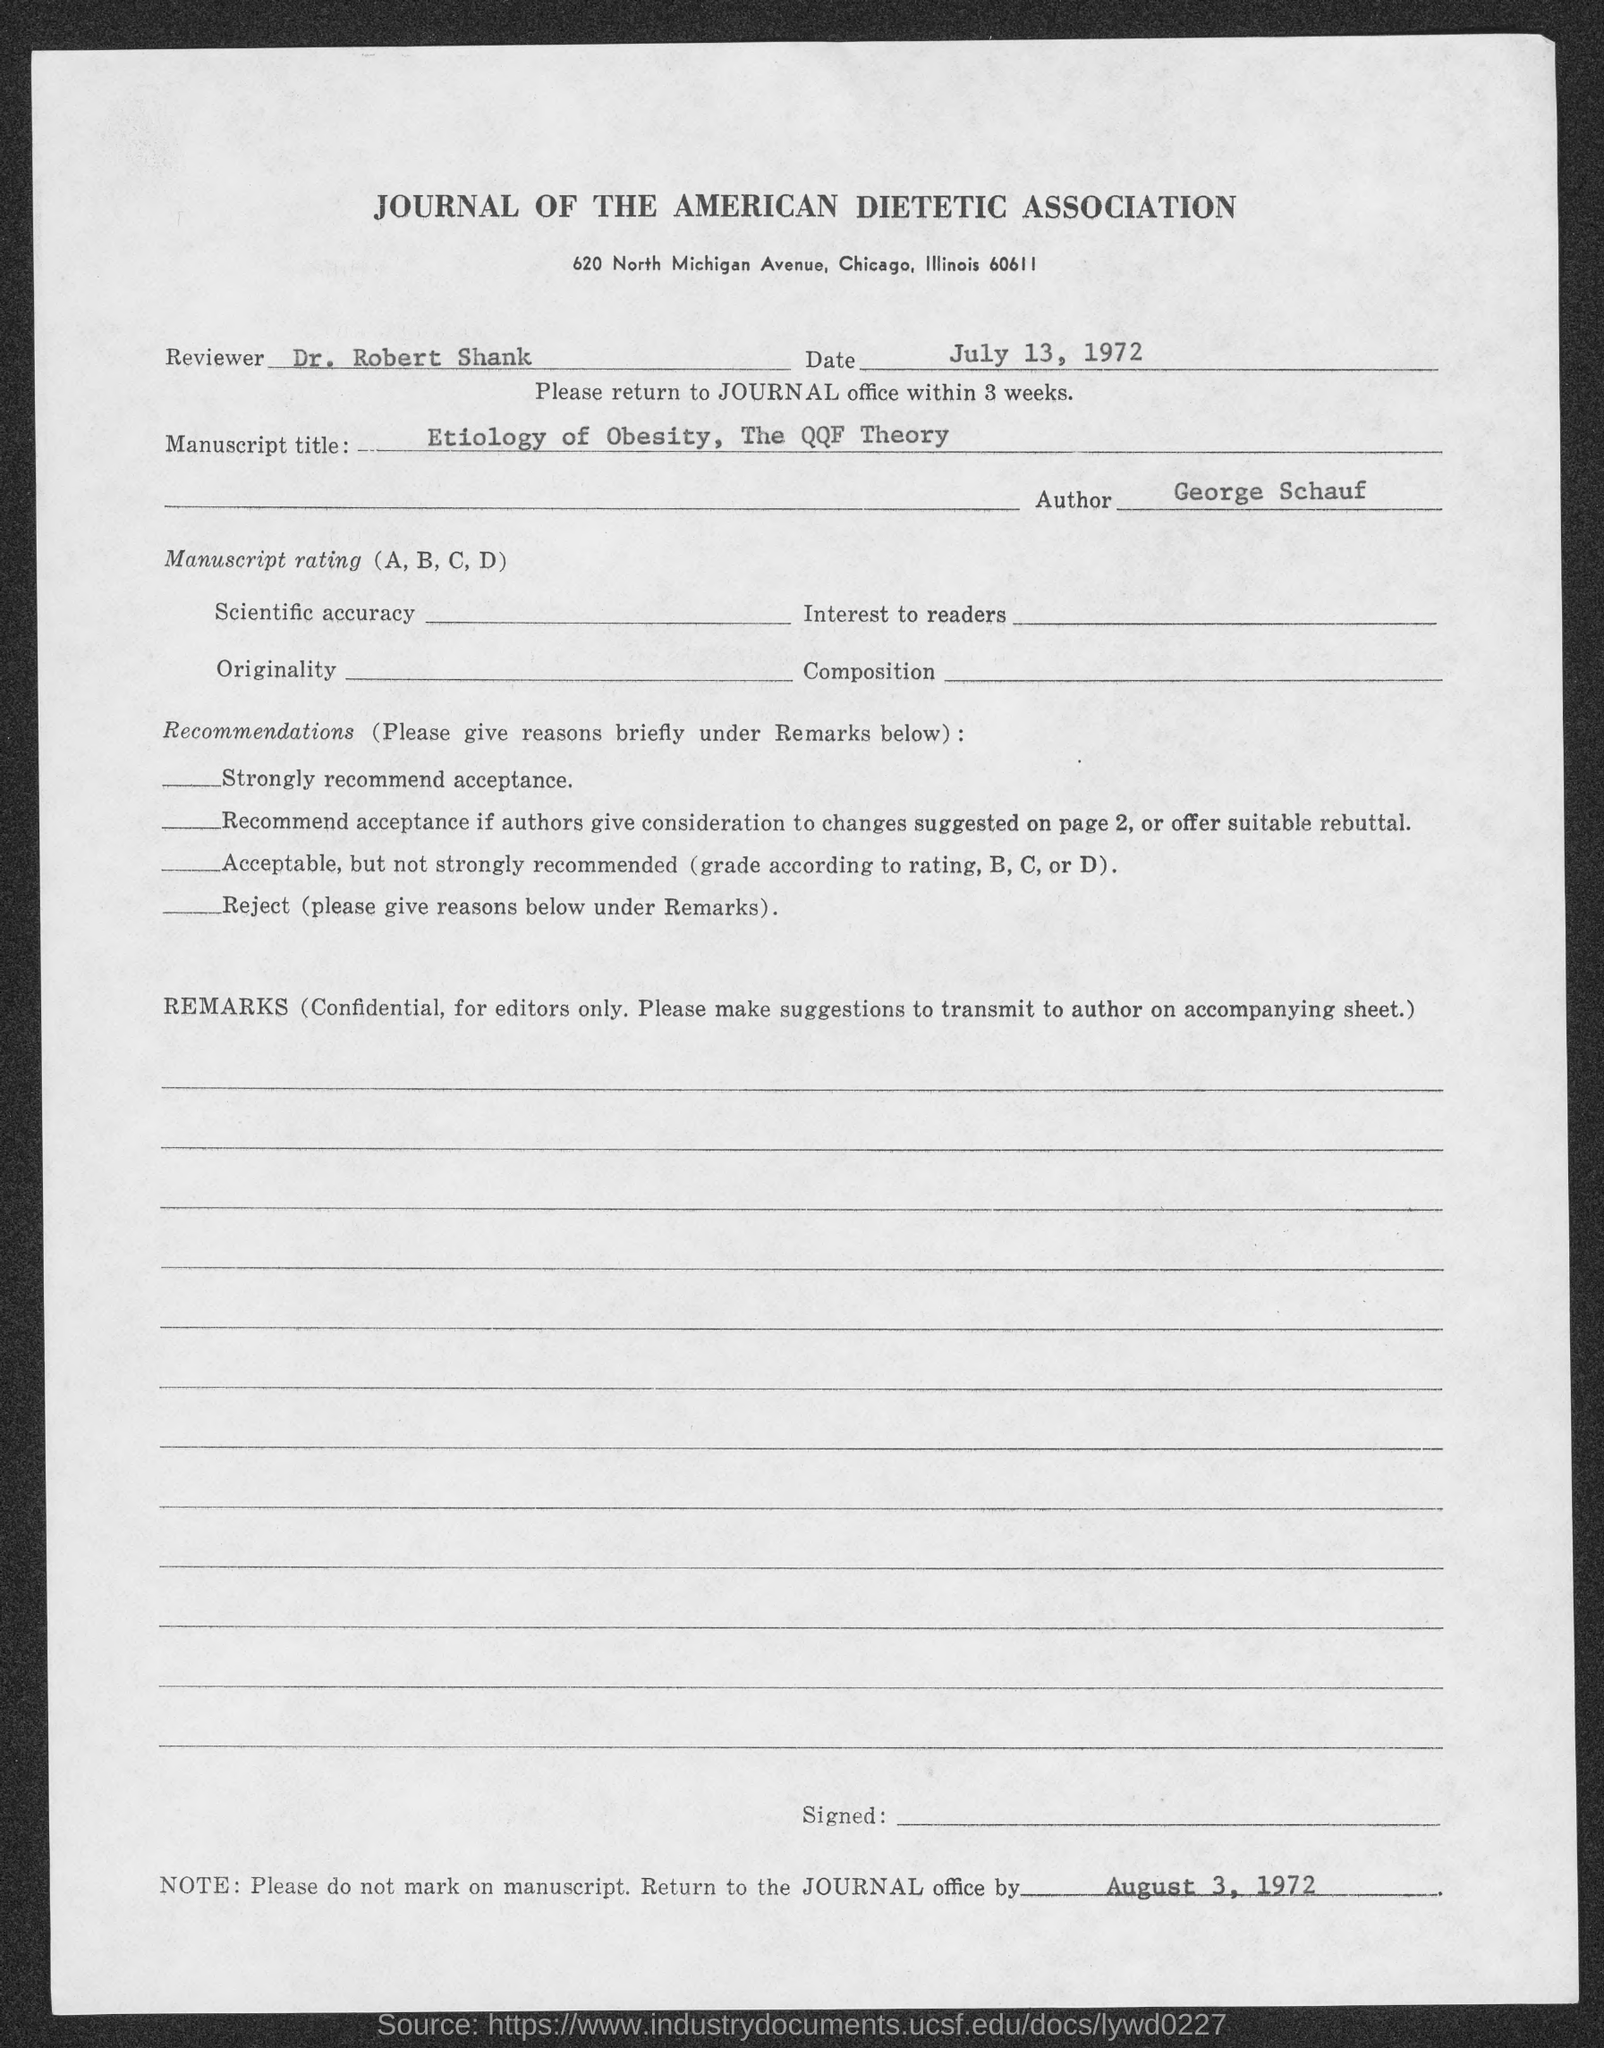Highlight a few significant elements in this photo. The author of the text is George Schauf. The reviewer is Dr. Robert Shank. The date is July 13, 1972. The journal office is instructed to be returned to by August 3, 1972. 